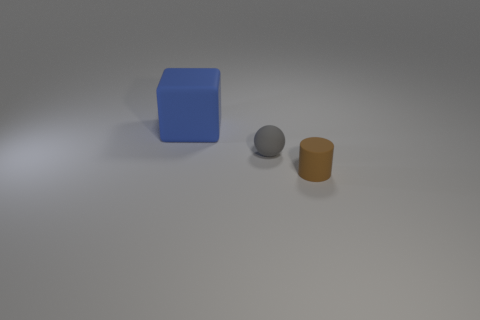Is there a small gray rubber object in front of the small rubber object on the left side of the tiny thing on the right side of the gray matte object?
Provide a succinct answer. No. There is a matte object on the left side of the tiny gray object; does it have the same color as the small thing that is to the left of the brown object?
Make the answer very short. No. There is a gray ball that is the same size as the brown cylinder; what is its material?
Your answer should be compact. Rubber. There is a rubber thing that is on the right side of the small object that is behind the thing in front of the gray rubber sphere; how big is it?
Give a very brief answer. Small. How many other things are the same material as the gray ball?
Offer a very short reply. 2. There is a object that is in front of the gray rubber sphere; what is its size?
Your answer should be compact. Small. What number of rubber things are behind the small gray rubber sphere and on the right side of the blue cube?
Ensure brevity in your answer.  0. Are any purple things visible?
Your answer should be very brief. No. There is a blue object that is made of the same material as the sphere; what shape is it?
Your response must be concise. Cube. There is a object right of the small matte sphere; what is it made of?
Your response must be concise. Rubber. 